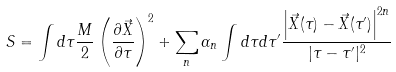Convert formula to latex. <formula><loc_0><loc_0><loc_500><loc_500>S = \int d \tau \frac { M } { 2 } \left ( \frac { \partial { \vec { X } } } { \partial \tau } \right ) ^ { 2 } + \sum _ { n } \alpha _ { n } \int d \tau d \tau ^ { \prime } \frac { \left | { \vec { X } } ( \tau ) - { \vec { X } } ( \tau ^ { \prime } ) \right | ^ { 2 n } } { | \tau - \tau ^ { \prime } | ^ { 2 } }</formula> 